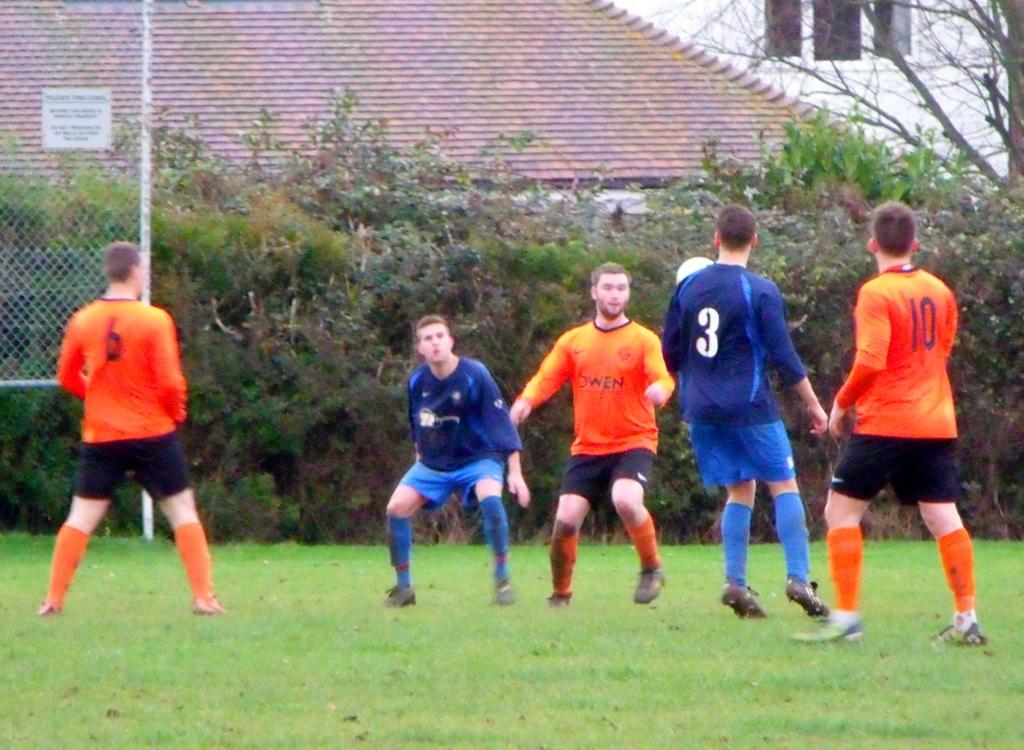Provide a one-sentence caption for the provided image. Some kids are playing soccer and one of them is named Owen. 